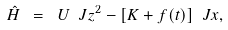Convert formula to latex. <formula><loc_0><loc_0><loc_500><loc_500>\hat { H } \ = \ U \ J z ^ { 2 } - [ K + f ( t ) ] \ J x ,</formula> 